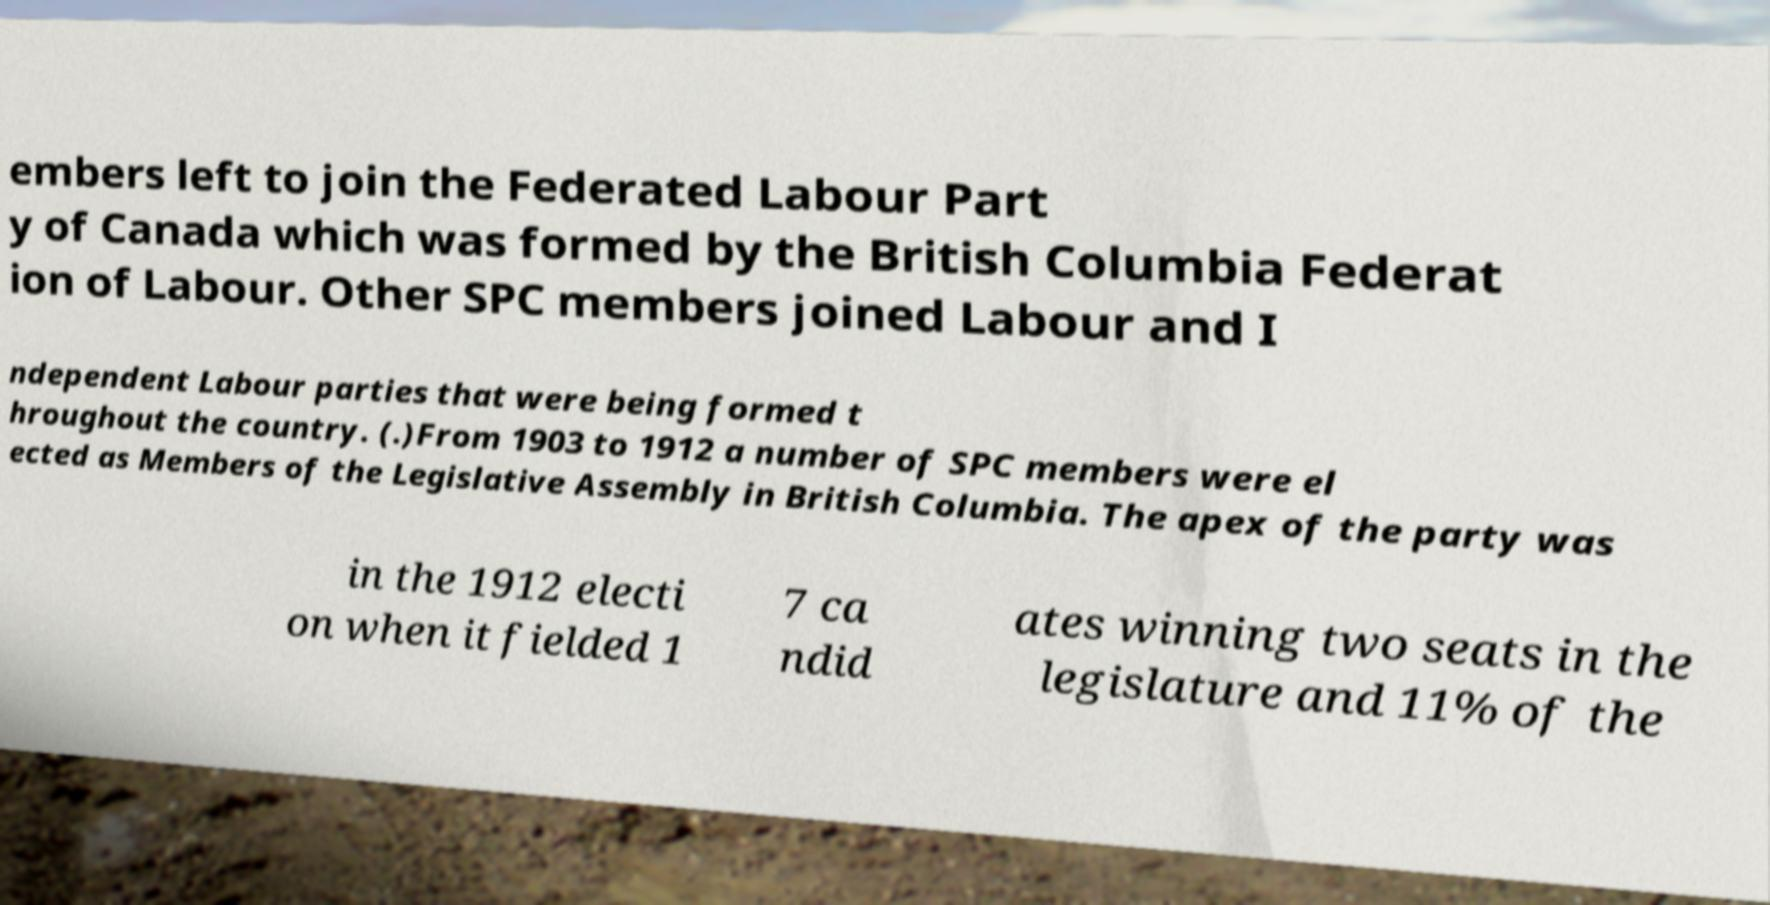Could you assist in decoding the text presented in this image and type it out clearly? embers left to join the Federated Labour Part y of Canada which was formed by the British Columbia Federat ion of Labour. Other SPC members joined Labour and I ndependent Labour parties that were being formed t hroughout the country. (.)From 1903 to 1912 a number of SPC members were el ected as Members of the Legislative Assembly in British Columbia. The apex of the party was in the 1912 electi on when it fielded 1 7 ca ndid ates winning two seats in the legislature and 11% of the 